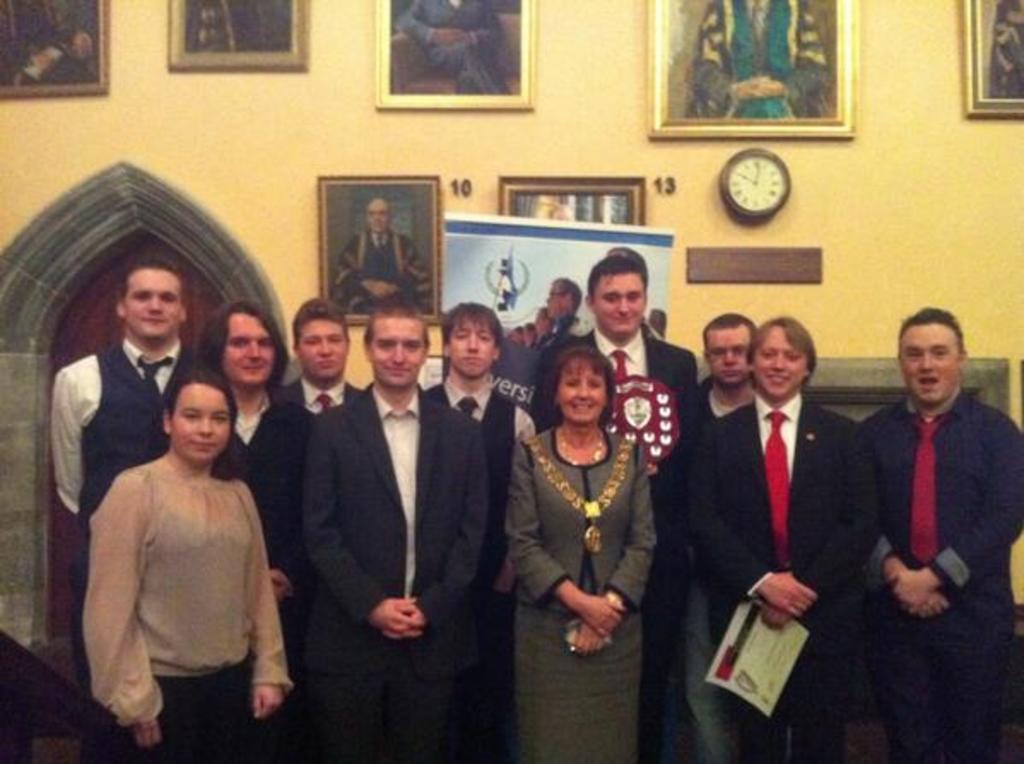What can be seen in the foreground of the image? There are people standing in the foreground of the image. What is located in the background of the image? There is a wall with photo frames and a clock on the wall in the background of the image. Can you describe the door in the background of the image? There is a door in the background of the image. How many mint leaves are on the door in the image? There are no mint leaves present in the image. Can you tell me what type of horse is depicted in one of the photo frames on the wall? There is no horse depicted in any of the photo frames on the wall in the image. 